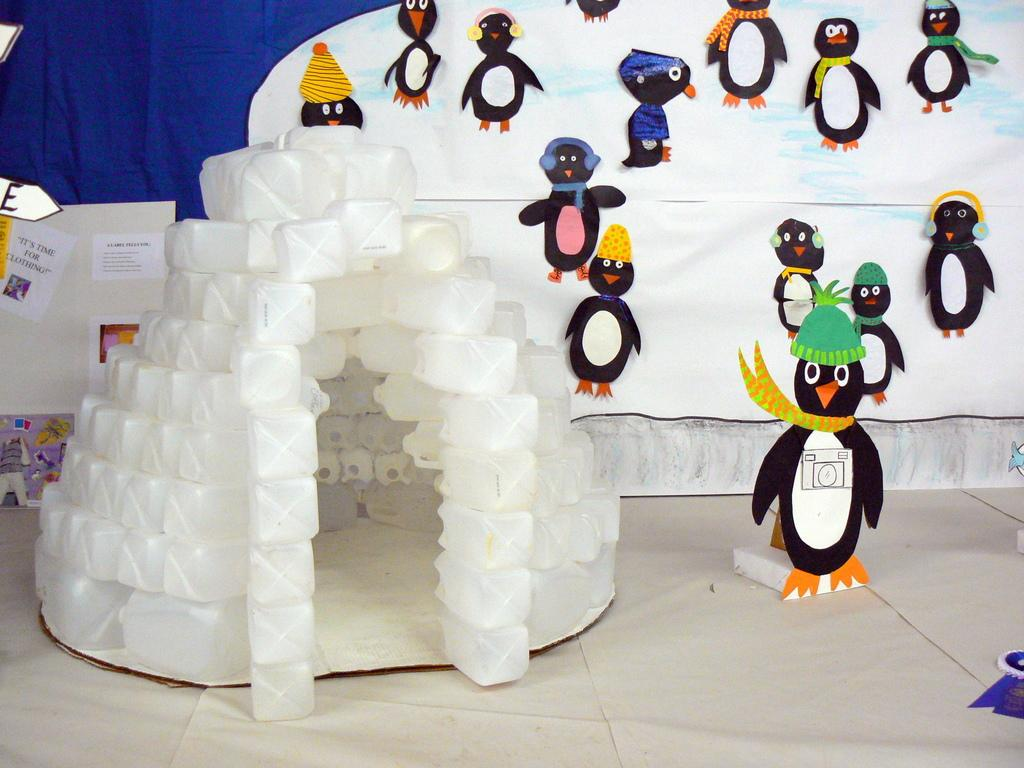What type of structure is present in the image? There is a house in the image. What objects are near the house? There are cans near the house. What is visible at the bottom of the image? There is a floor visible at the bottom of the image. What type of crafts can be seen in the image? There are paper crafts in the image. What type of decorations are present in the image? There are posters in the image. What type of material is visible in the right side and background of the image? There is cloth visible in the right side and background of the image. Can you see a dock near the house in the image? There is no dock present in the image. Are there any parents visible in the image? The image does not show any people, so it is not possible to determine if there are any parents present. 